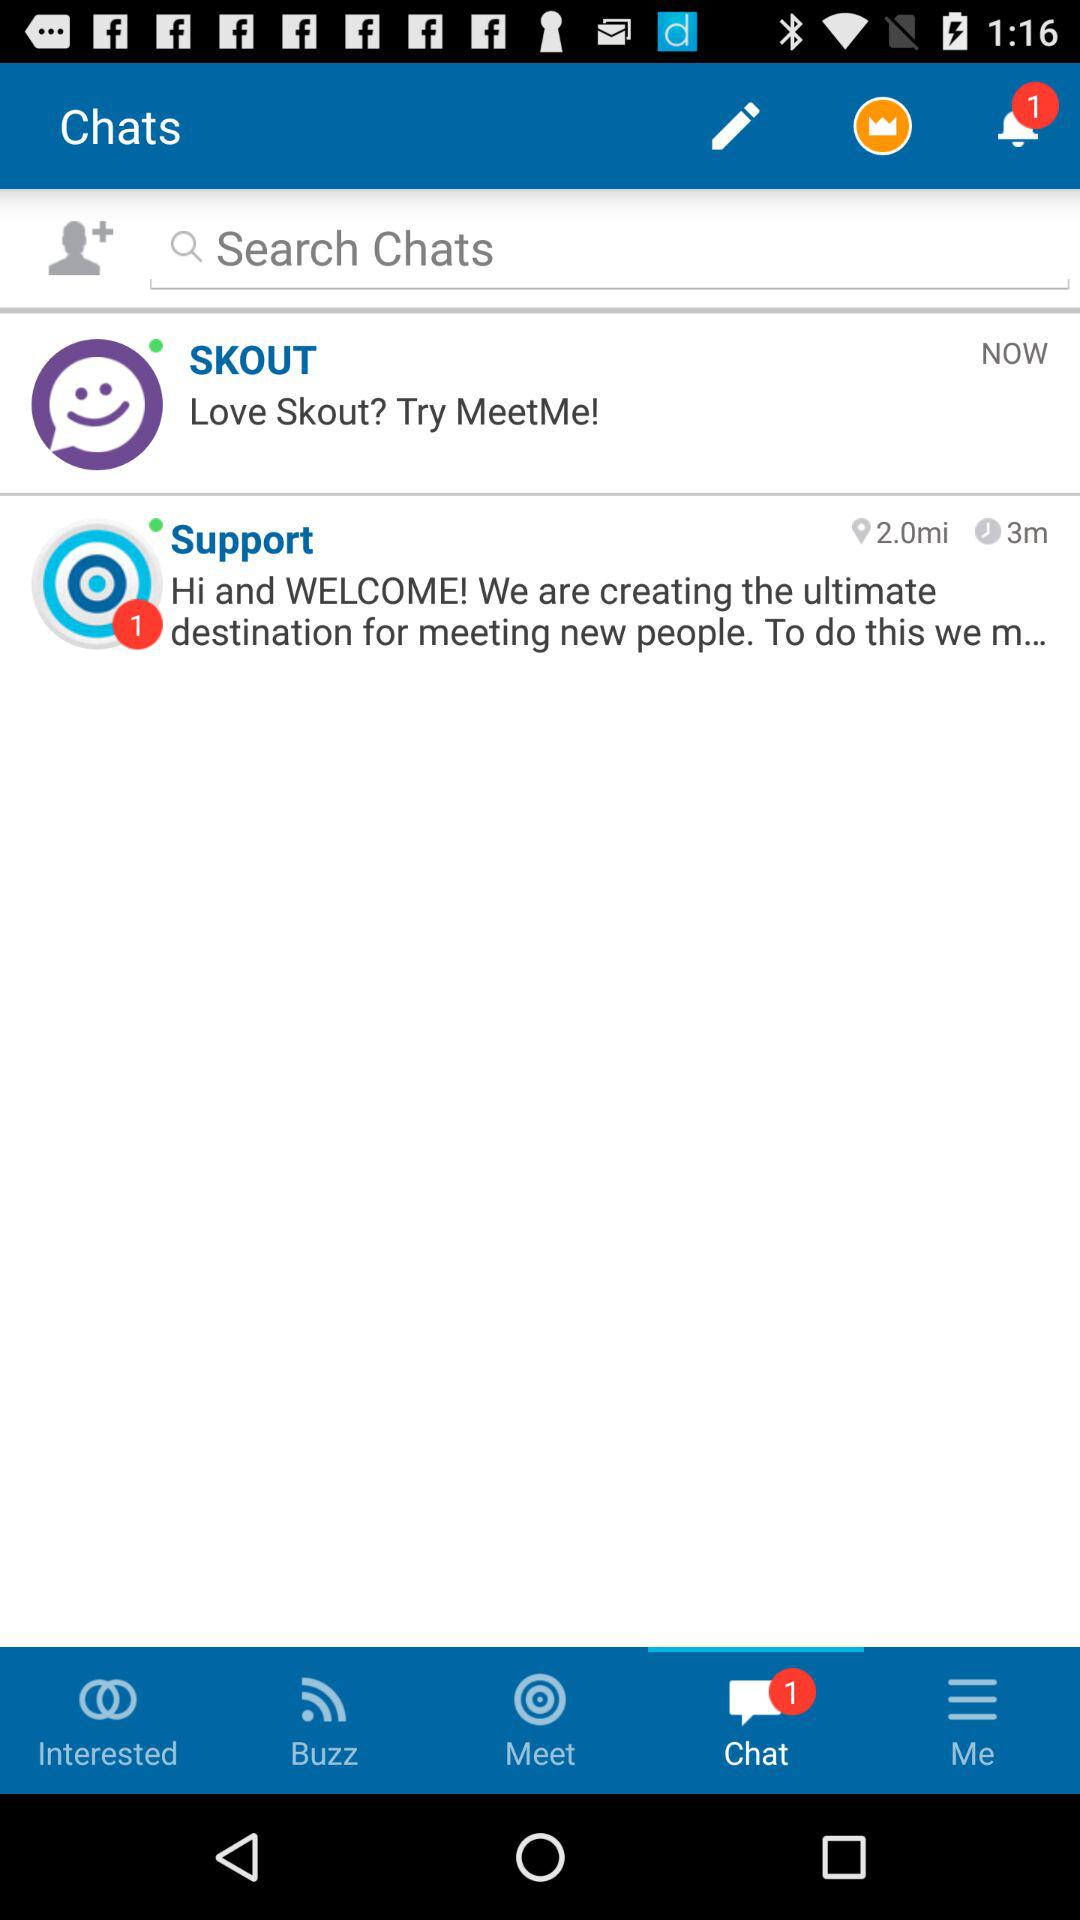Is there any unread chat?
When the provided information is insufficient, respond with <no answer>. <no answer> 